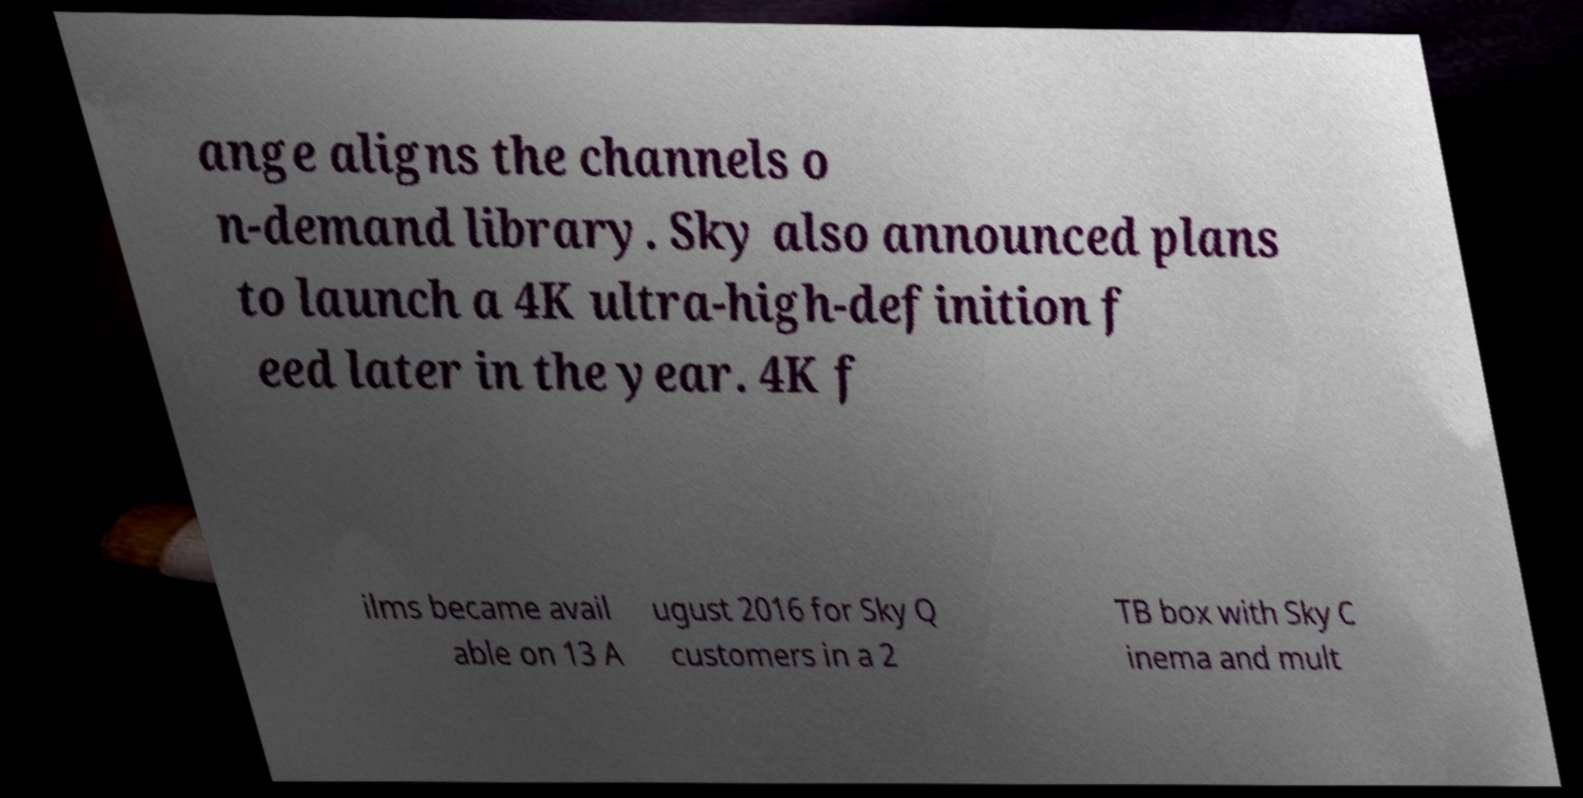Please identify and transcribe the text found in this image. ange aligns the channels o n-demand library. Sky also announced plans to launch a 4K ultra-high-definition f eed later in the year. 4K f ilms became avail able on 13 A ugust 2016 for Sky Q customers in a 2 TB box with Sky C inema and mult 